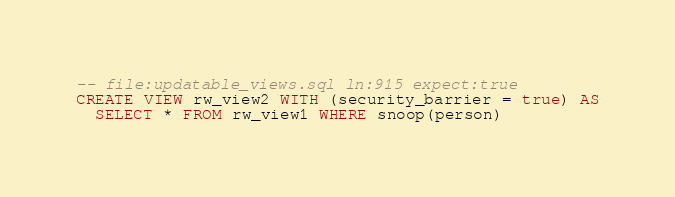Convert code to text. <code><loc_0><loc_0><loc_500><loc_500><_SQL_>-- file:updatable_views.sql ln:915 expect:true
CREATE VIEW rw_view2 WITH (security_barrier = true) AS
  SELECT * FROM rw_view1 WHERE snoop(person)
</code> 